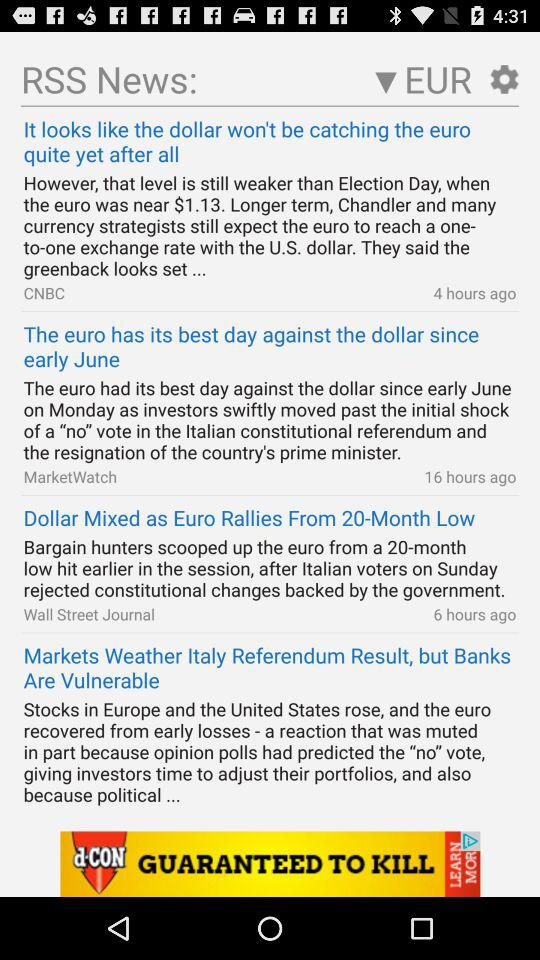When was the news "Dollar Mixed As Euro Rallies From 20-Month Low" posted? The news "Dollar Mixed As Euro Rallies From 20-Month Low" was posted 6 hours ago. 